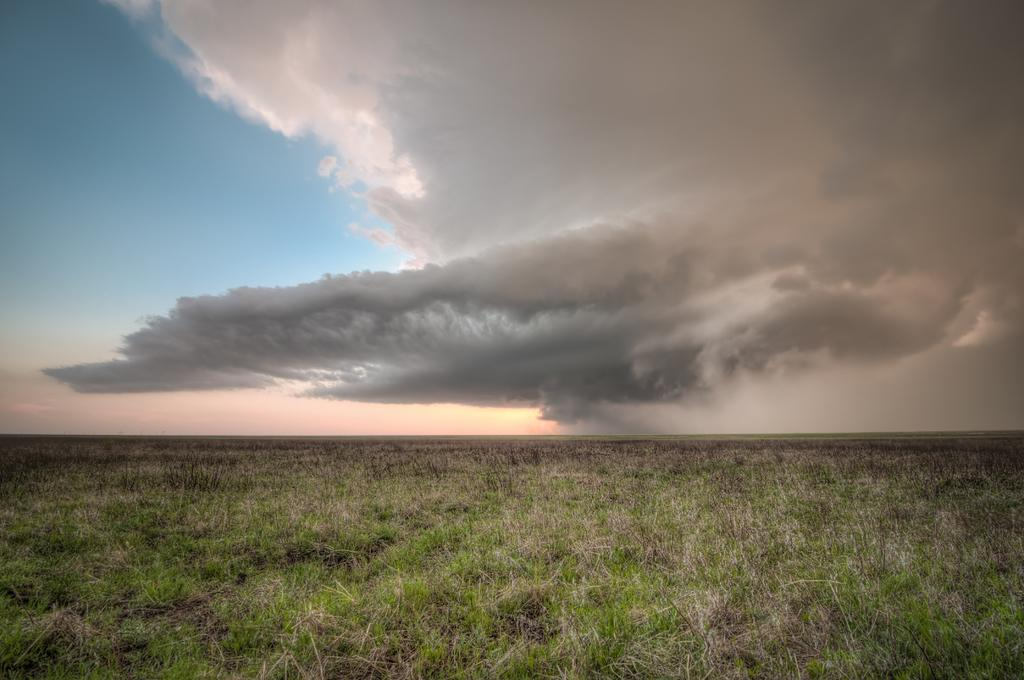What type of vegetation is on the ground in the image? There is dry grass on the ground in the image. What is the condition of the sky in the image? The sky is cloudy in the image. Where is the jar of stitches located in the image? There is no jar of stitches present in the image. What type of receipt can be seen in the image? There is no receipt present in the image. 